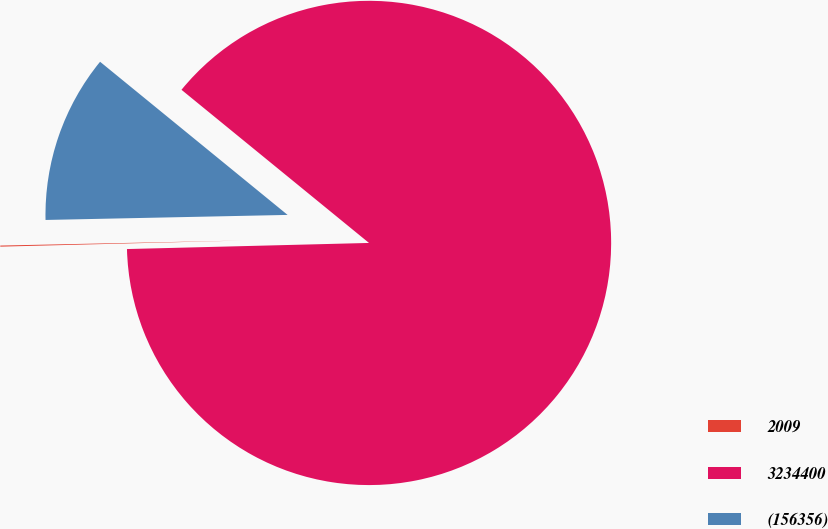Convert chart to OTSL. <chart><loc_0><loc_0><loc_500><loc_500><pie_chart><fcel>2009<fcel>3234400<fcel>(156356)<nl><fcel>0.07%<fcel>88.69%<fcel>11.23%<nl></chart> 